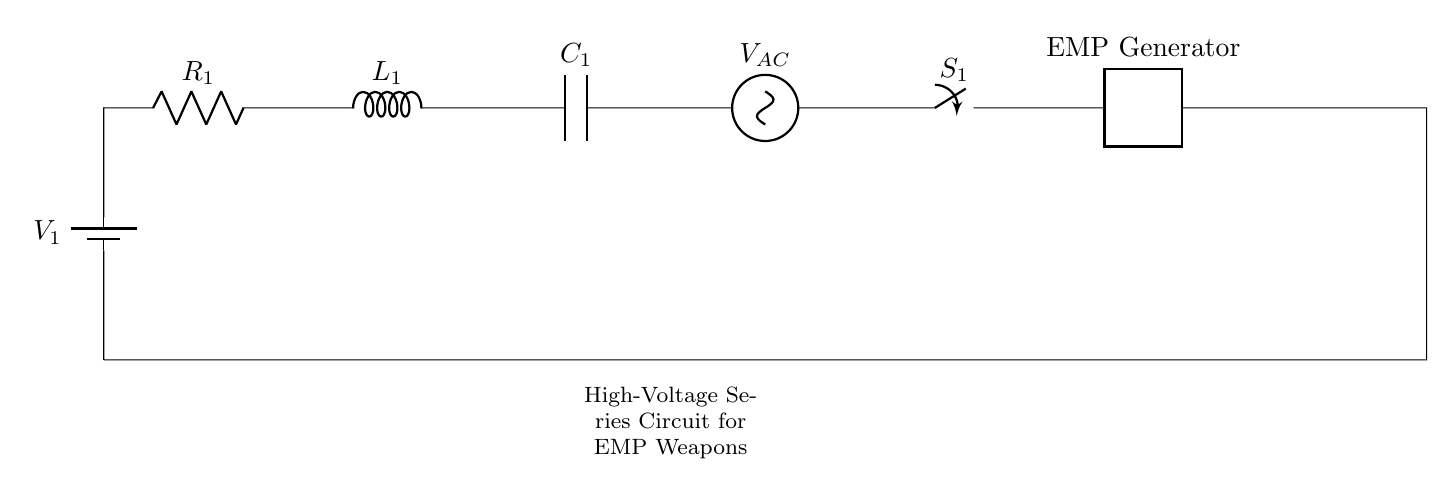What type of circuit is shown in the diagram? The diagram depicts a series circuit, as all components are connected end-to-end in a single path for current flow.
Answer: series circuit What is the component labeled as C1? The component labeled as C1 represents a capacitor, which stores electrical energy in an electric field.
Answer: capacitor What is the purpose of the switch S1 in this circuit? The switch S1 controls the current flow in the circuit; when closed, it completes the circuit allowing current to flow, and when open, it interrupts the current.
Answer: control current flow What does the EMP generator do in this circuit? The EMP generator converts the electrical energy supplied to it into an electromagnetic pulse, which can disrupt or damage electronic devices.
Answer: generate electromagnetic pulse How many total components are visible in the circuit diagram? There are six visible components in the circuit: a battery, resistor, inductor, capacitor, AC voltage source, and an EMP generator.
Answer: six components What role does the inductor L1 play in this circuit? The inductor L1 stores energy in a magnetic field when current passes through it, which can affect the timing and transient response of the circuit, especially useful in pulsating signals such as those from the EMP generator.
Answer: store energy What is the function of the antenna in the circuit? The antenna transmits the generated electromagnetic pulse into the surrounding environment, making it effective in deploying the EMP effects.
Answer: transmit electromagnetic pulse 